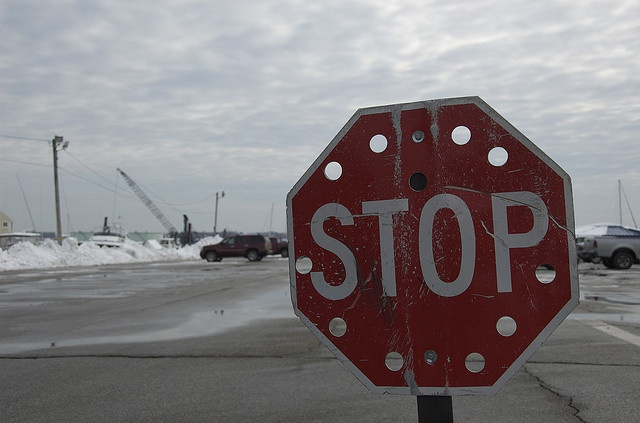Describe the objects in this image and their specific colors. I can see stop sign in darkgray, maroon, and gray tones, car in darkgray, black, gray, and purple tones, truck in darkgray, gray, black, and purple tones, boat in darkgray, gray, and lightgray tones, and car in darkgray, black, gray, and lightgray tones in this image. 